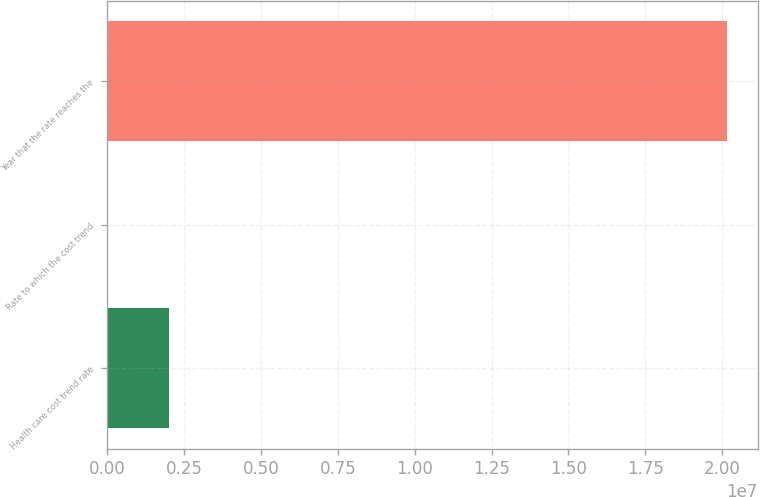Convert chart. <chart><loc_0><loc_0><loc_500><loc_500><bar_chart><fcel>Health care cost trend rate<fcel>Rate to which the cost trend<fcel>Year that the rate reaches the<nl><fcel>2.01521e+06<fcel>5<fcel>2.0152e+07<nl></chart> 